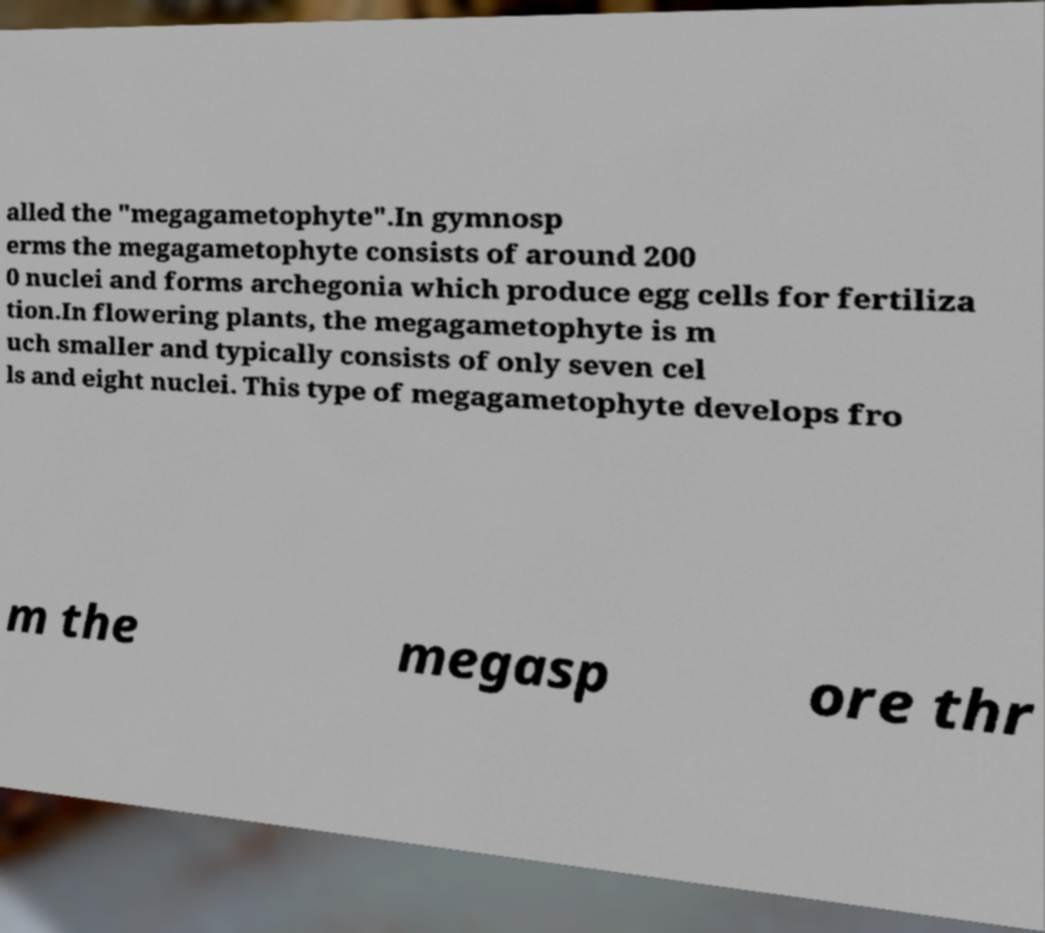What messages or text are displayed in this image? I need them in a readable, typed format. alled the "megagametophyte".In gymnosp erms the megagametophyte consists of around 200 0 nuclei and forms archegonia which produce egg cells for fertiliza tion.In flowering plants, the megagametophyte is m uch smaller and typically consists of only seven cel ls and eight nuclei. This type of megagametophyte develops fro m the megasp ore thr 